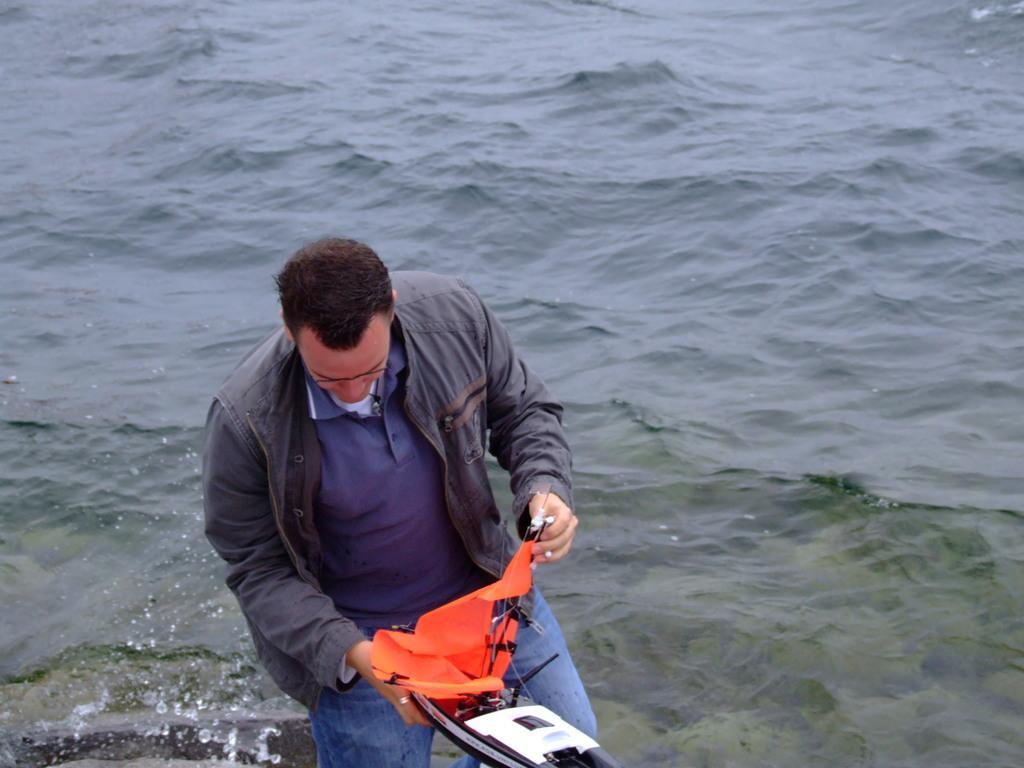In one or two sentences, can you explain what this image depicts? In this image, I can see the man standing and holding an object in his hands. I can see the water flowing. I think this is a toy remote control ship. 